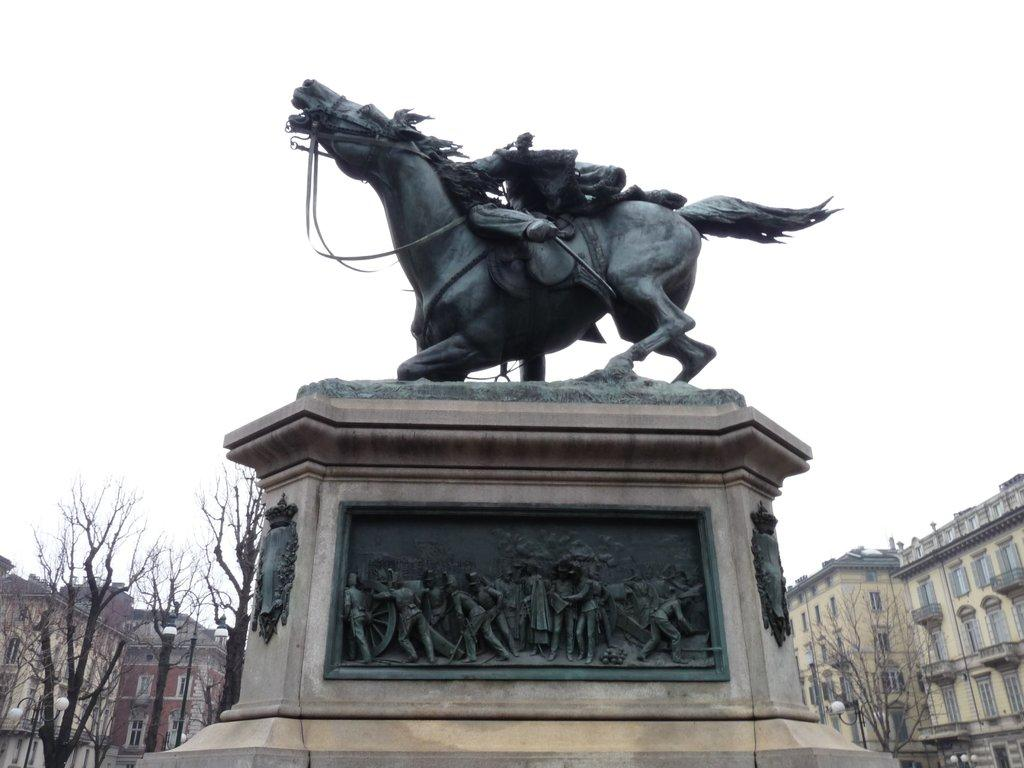What is the main subject in the image? There is a statue in the image. Can you describe the statue? The statue is black in color. What can be seen in the background of the image? There are buildings, windows, dry trees, and light poles visible in the background. How would you describe the sky in the image? The sky is white in color. Is there a stranger standing next to the statue in the image? There is no stranger present in the image; it only features the statue and the background elements. Is there a fire burning near the dry trees in the image? There is no fire visible in the image; only dry trees are present in the background. 